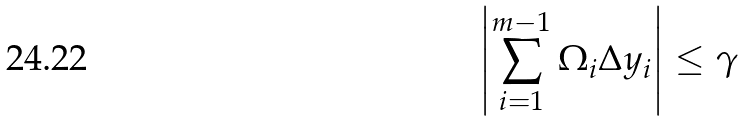Convert formula to latex. <formula><loc_0><loc_0><loc_500><loc_500>\left | \sum _ { i = 1 } ^ { m - 1 } \Omega _ { i } \Delta y _ { i } \right | \leq \gamma</formula> 